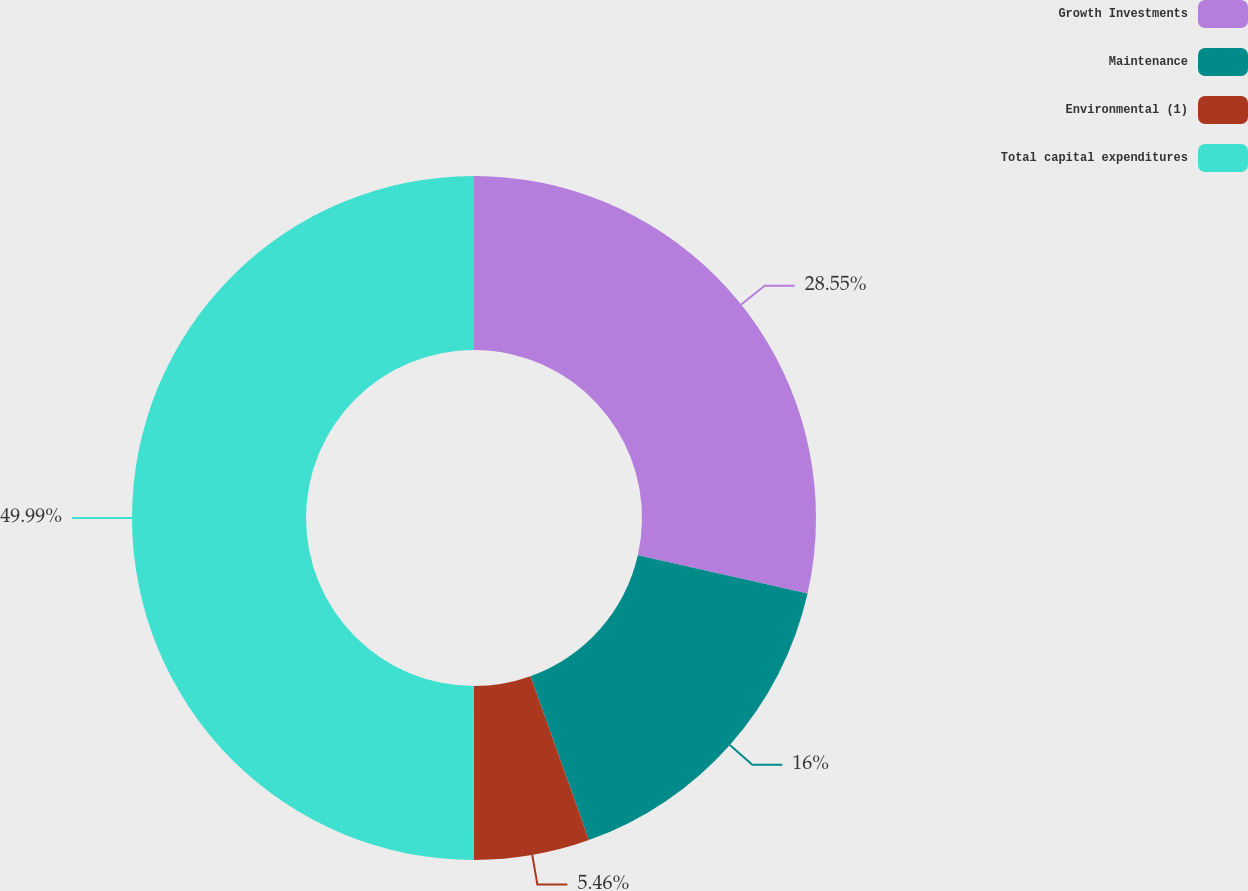Convert chart to OTSL. <chart><loc_0><loc_0><loc_500><loc_500><pie_chart><fcel>Growth Investments<fcel>Maintenance<fcel>Environmental (1)<fcel>Total capital expenditures<nl><fcel>28.55%<fcel>16.0%<fcel>5.46%<fcel>50.0%<nl></chart> 